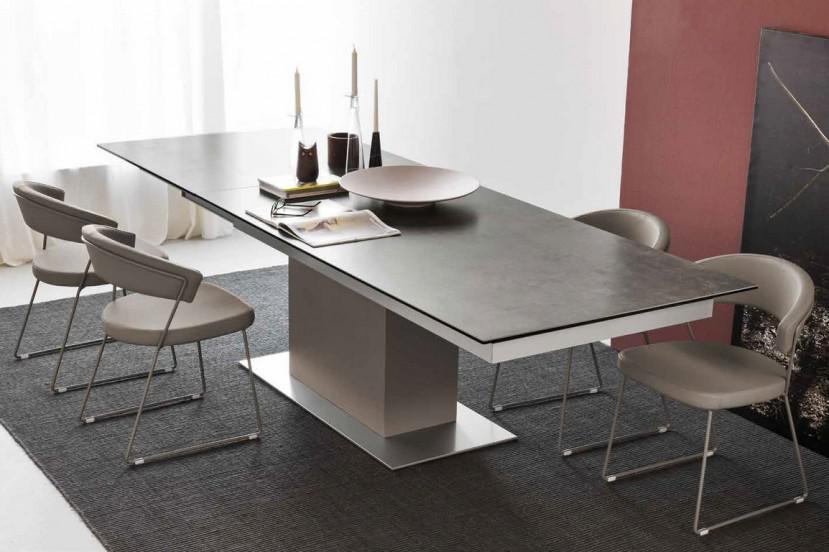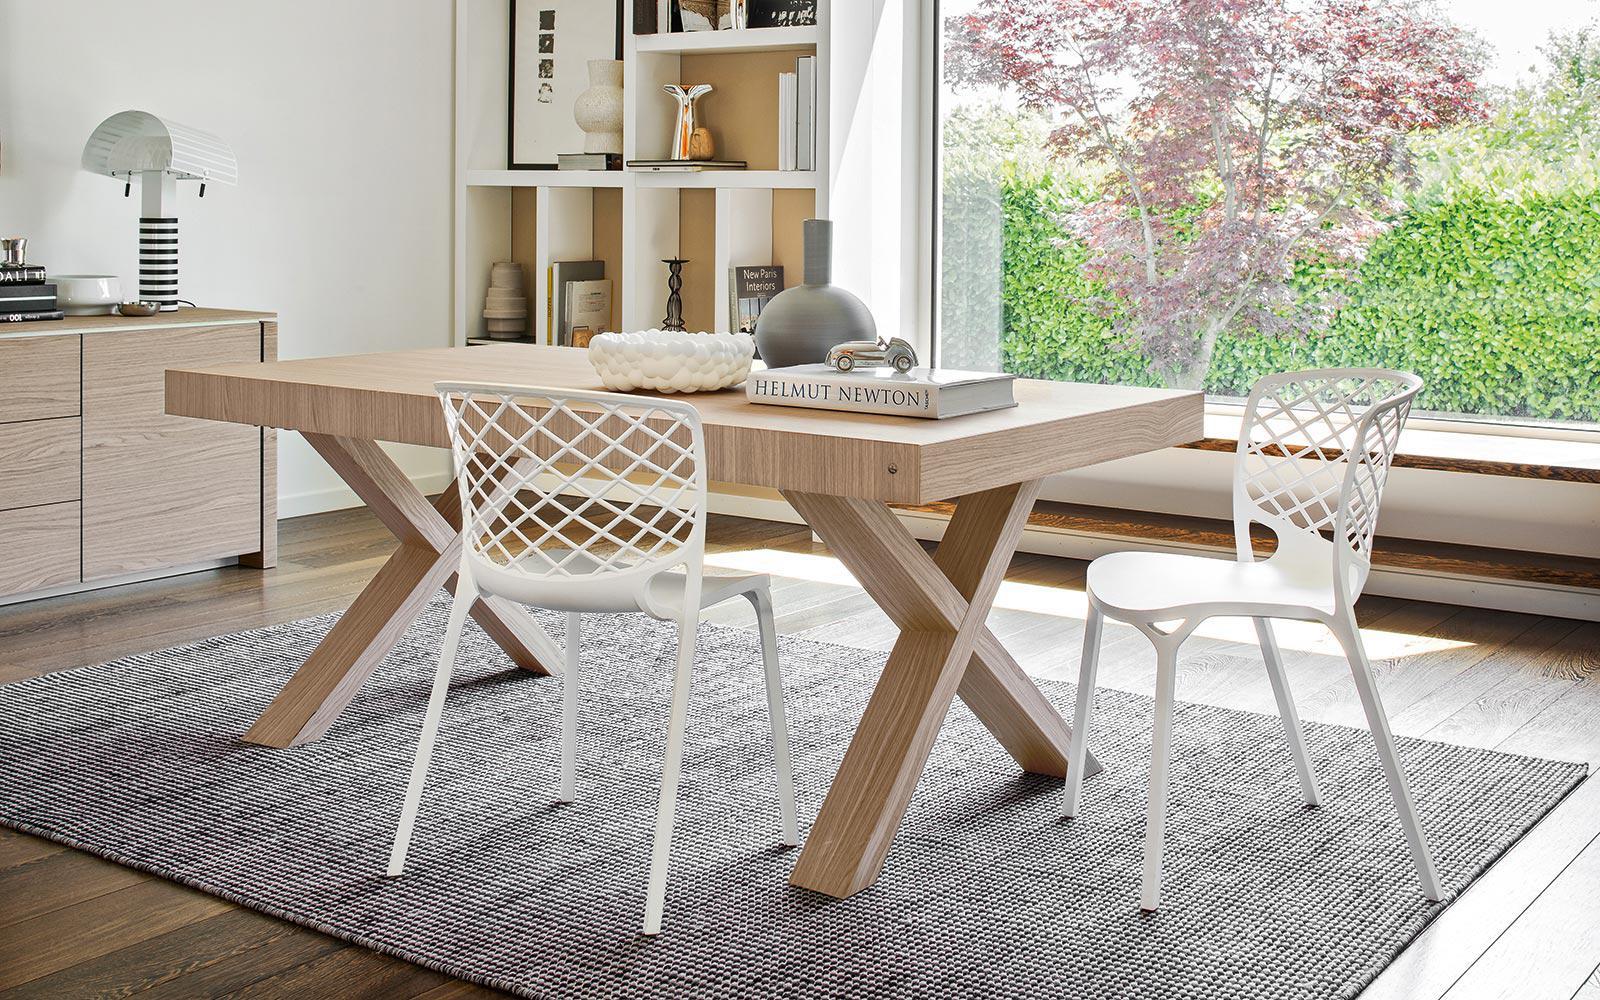The first image is the image on the left, the second image is the image on the right. For the images displayed, is the sentence "One image shows two white chairs with criss-crossed backs at a light wood table with X-shaped legs, and the other image shows a dark-topped rectangular table with a rectangular pedestal base." factually correct? Answer yes or no. Yes. The first image is the image on the left, the second image is the image on the right. For the images shown, is this caption "The legs on the table in one of the images is shaped like the letter """"x""""." true? Answer yes or no. Yes. 